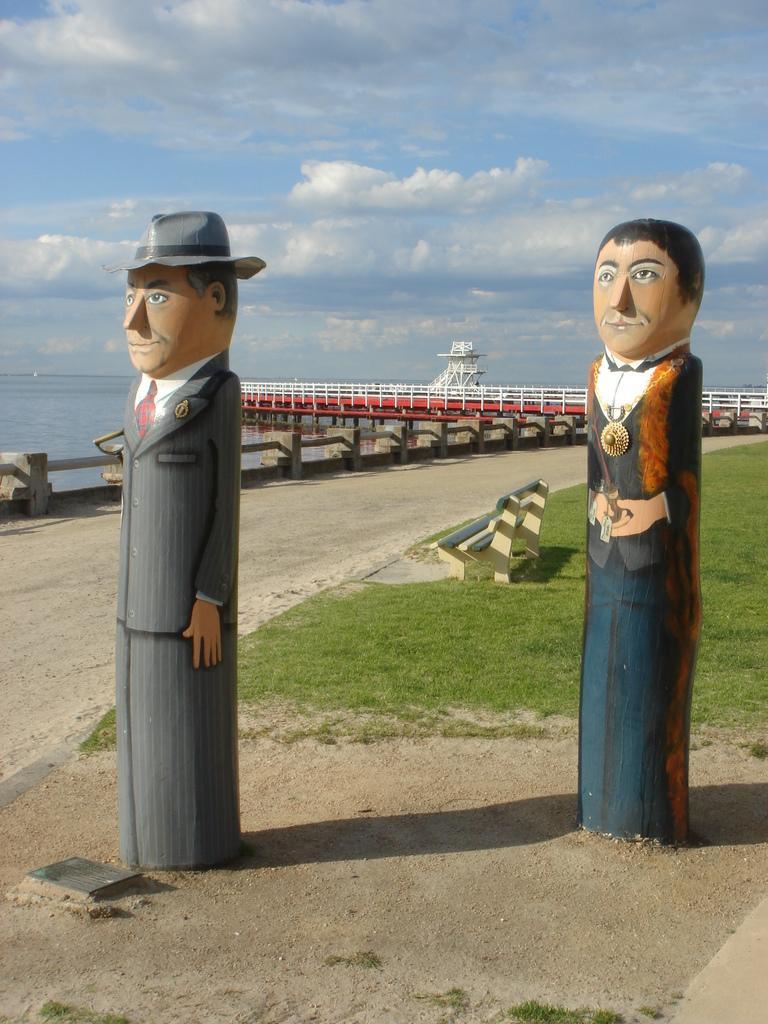Could you give a brief overview of what you see in this image? In this image we can see statues on the ground, a bench, railing, bridge, water and the sky with clouds in the background. 